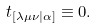<formula> <loc_0><loc_0><loc_500><loc_500>t _ { \left [ \lambda \mu \nu | \alpha \right ] } \equiv 0 .</formula> 